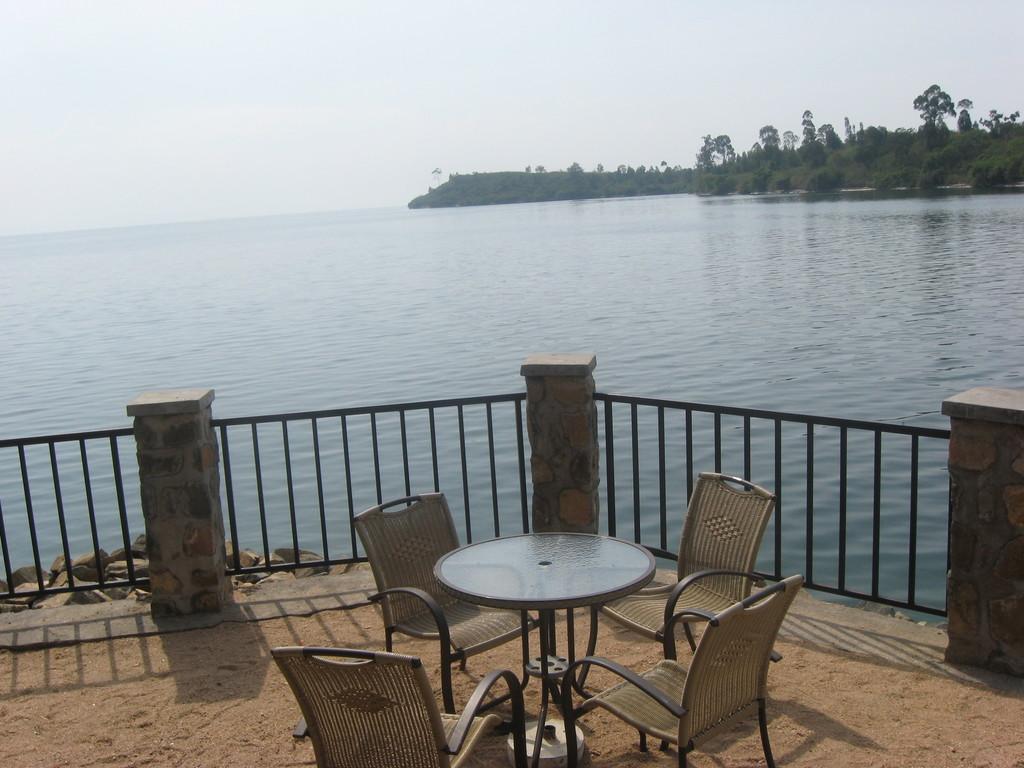Can you describe this image briefly? In this image I can see the table and the four chairs. To the side of the table I can see the railing. In the background I can see the water, trees and also the white sky. 